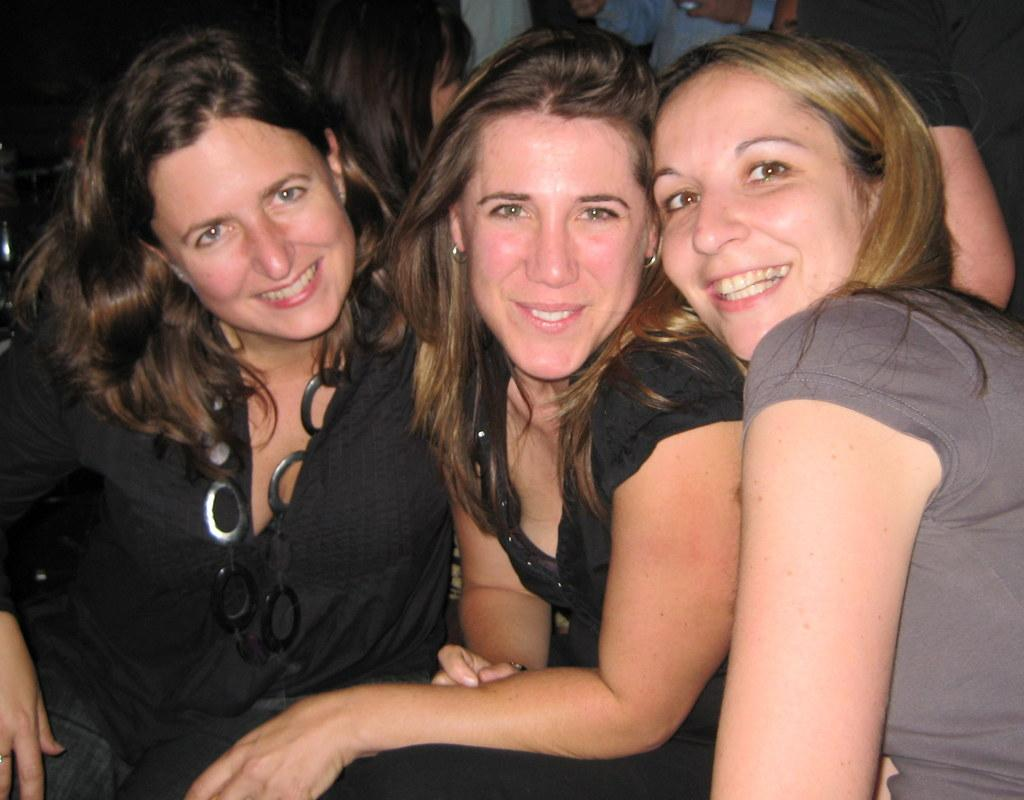How many women are in the image? There are three women in the image. What are the women doing in the image? The women are sitting together. What expressions do the women have in the image? The women are smiling. What colors are the dresses of the two women wearing black dresses? The dresses of the two women wearing black dresses are black. What color is the dress of the woman wearing a different color? The woman wearing a different color is wearing a gray dress. What type of digestion issues are the women discussing in the image? There is no indication in the image that the women are discussing digestion issues or any other specific topic. 